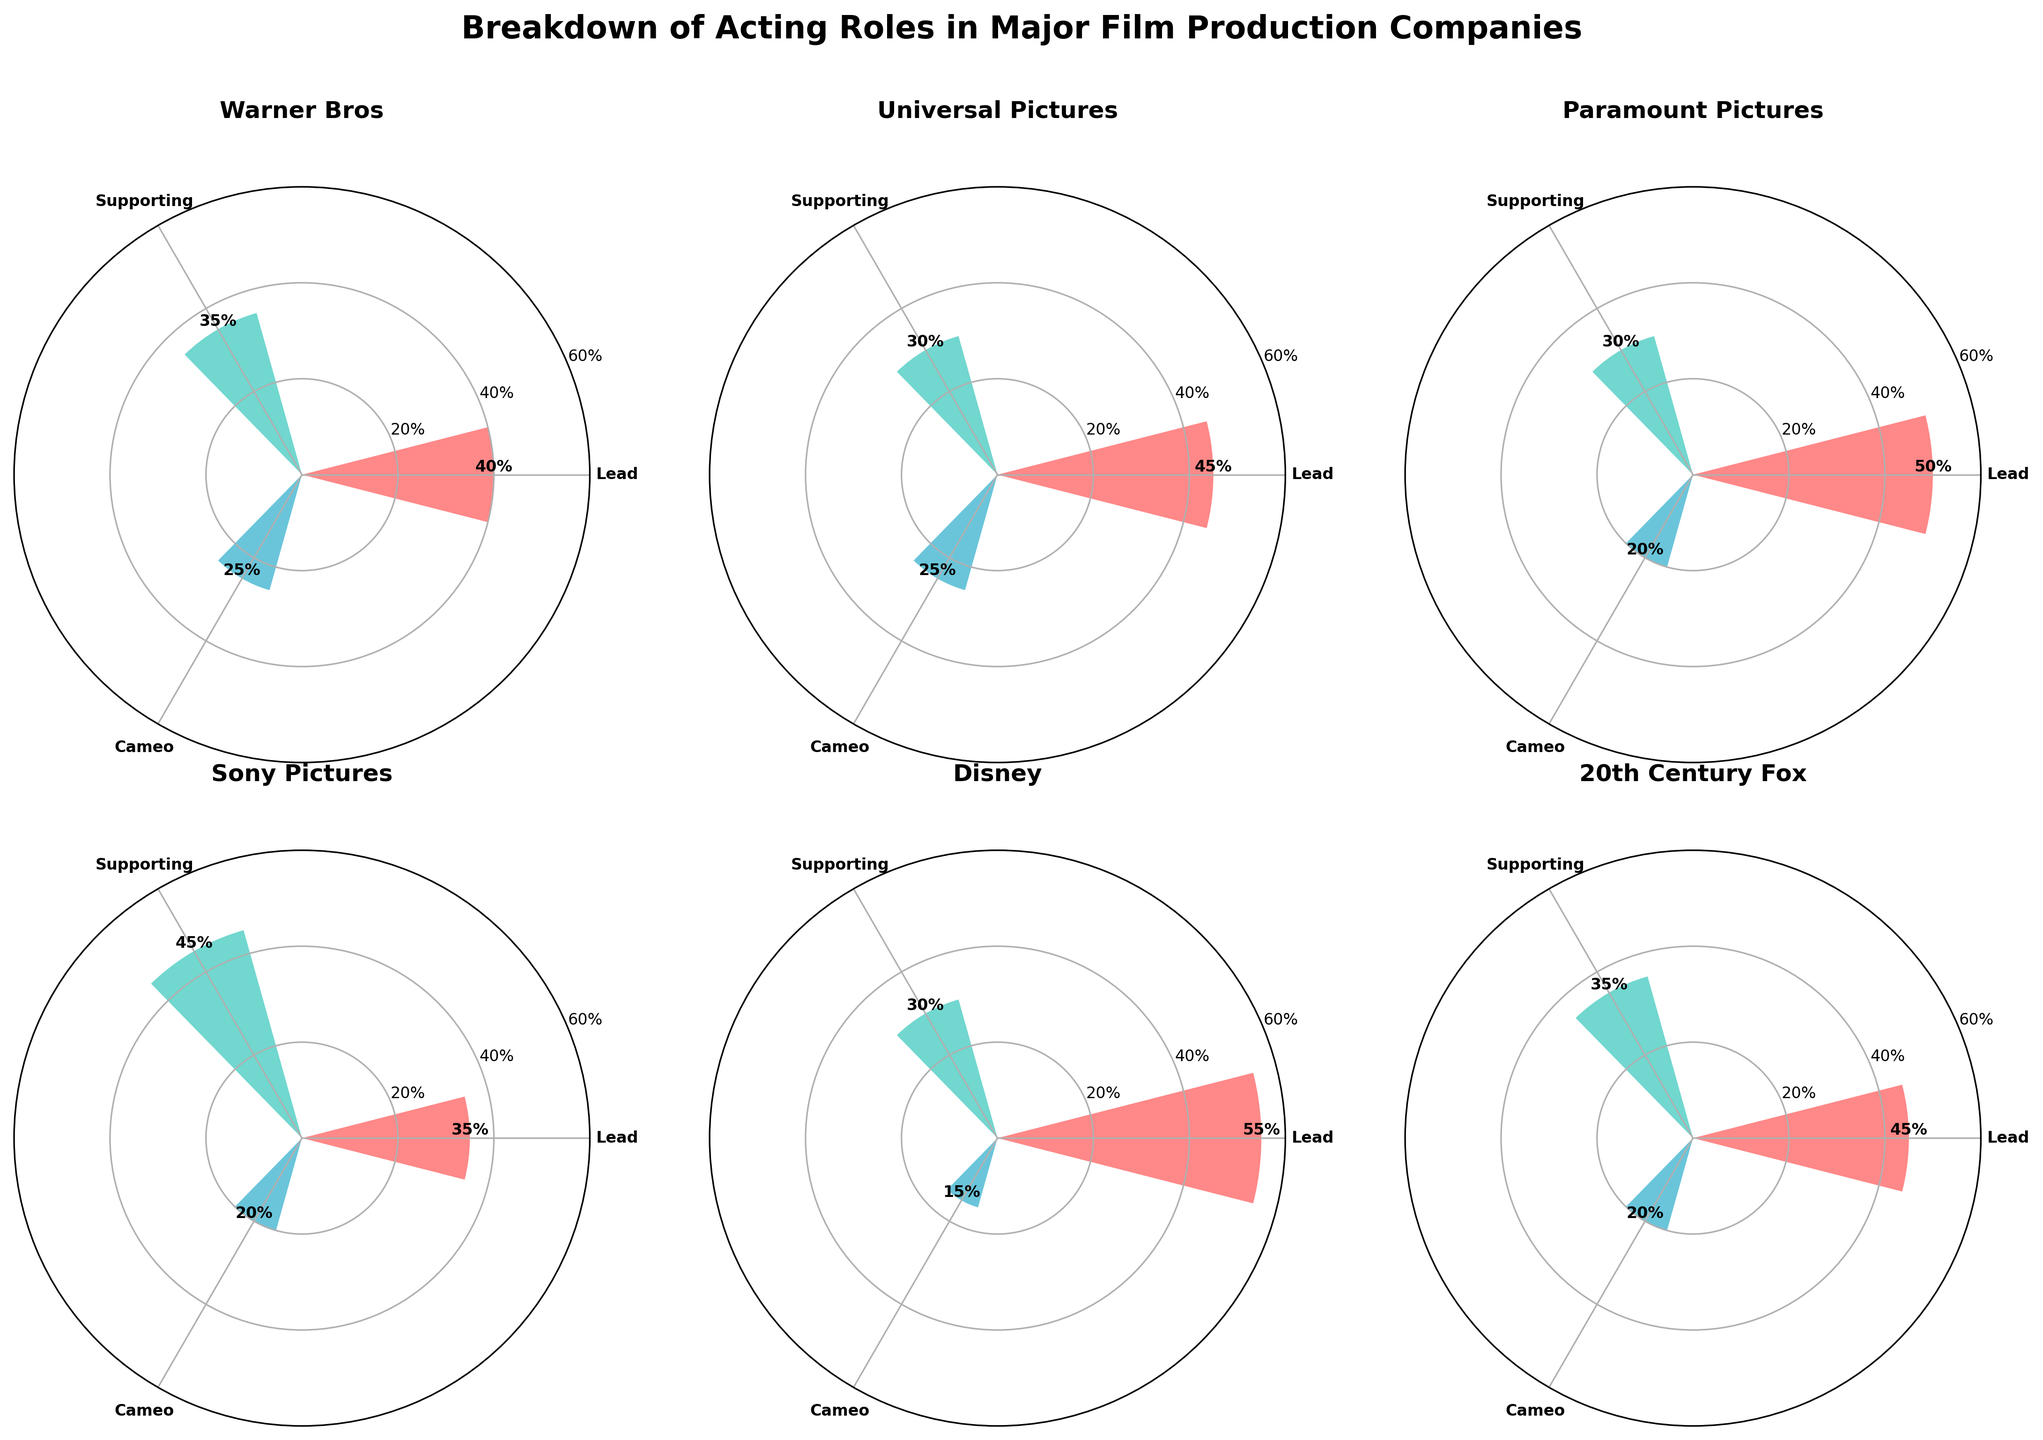What is the title of the entire figure? The title is displayed prominently at the top of the figure, usually larger and bold. It should be read directly from the text above the charts.
Answer: Breakdown of Acting Roles in Major Film Production Companies Which production company has the highest percentage of Lead roles? Look at the bars labeled "Lead" for each company and identify the one with the tallest bar.
Answer: Disney What is the percentage of Supporting roles in Sony Pictures? Focus on the plot corresponding to Sony Pictures and read the percentage label on the Supporting role bar.
Answer: 45% How does the percentage of Cameo roles in Warner Bros compare to that in Paramount Pictures? Compare the heights of the Cameo role bars in the Warner Bros and Paramount Pictures subplots.
Answer: Higher in Warner Bros What is the total percentage of Lead and Supporting roles in Universal Pictures? Identify the bars for Lead and Supporting roles in the Universal Pictures subplot, then sum the percentages given.
Answer: 75% Which production company has the smallest percentage of Cameo roles? Check the labels on the Cameo role bars for all companies and find the smallest percentage.
Answer: Disney Which role type has the highest percentage for 20th Century Fox? Look at the bars for 20th Century Fox and find the highest bar, noting its role type.
Answer: Lead What is the average percentage of Lead roles across all companies? Sum the percentages of Lead roles from each company and divide by the number of companies. Detailed calculation: (40 + 45 + 50 + 35 + 55 + 45) / 6 = 45%
Answer: 45% How does the total percentage of all role types in Disney compare to that in Warner Bros? Sum all the role type percentages for Disney and Warner Bros, then compare the totals. Disney: (55 + 30 + 15) = 100%, Warner Bros: (40 + 35 + 25) = 100%
Answer: Equal Which two companies have the same percentage for Cameo roles, and what is that percentage? Check the percentages for Cameo roles for all companies and identify any that are the same. Then note the percentage they share.
Answer: Warner Bros and Universal Pictures, 25% 